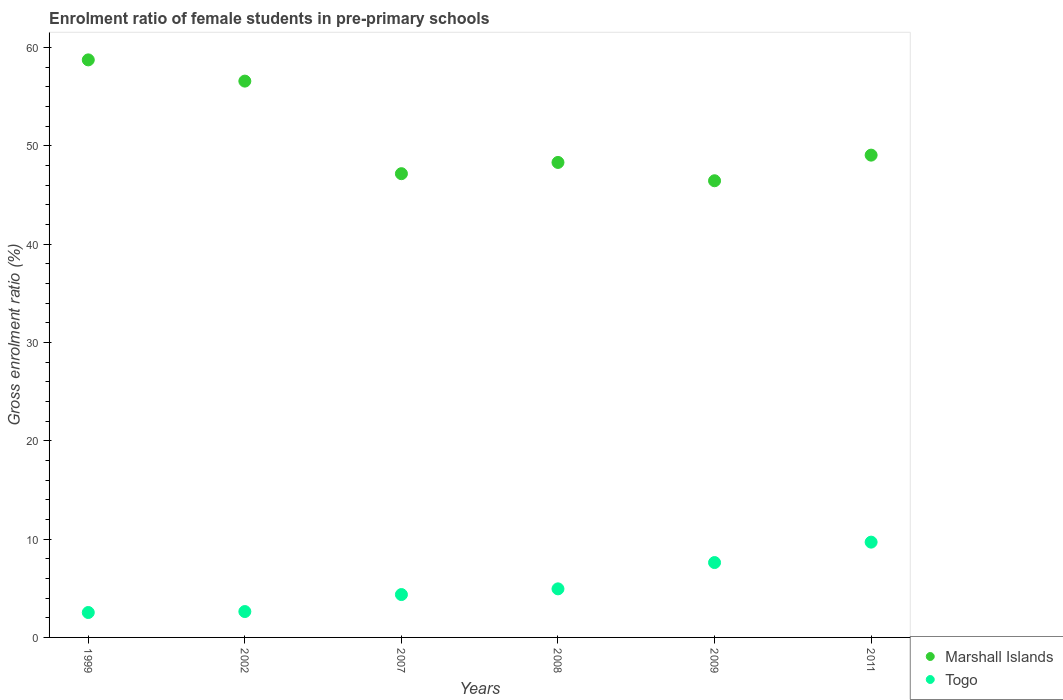How many different coloured dotlines are there?
Keep it short and to the point. 2. What is the enrolment ratio of female students in pre-primary schools in Togo in 2009?
Make the answer very short. 7.61. Across all years, what is the maximum enrolment ratio of female students in pre-primary schools in Togo?
Give a very brief answer. 9.69. Across all years, what is the minimum enrolment ratio of female students in pre-primary schools in Marshall Islands?
Your response must be concise. 46.44. What is the total enrolment ratio of female students in pre-primary schools in Togo in the graph?
Provide a succinct answer. 31.77. What is the difference between the enrolment ratio of female students in pre-primary schools in Marshall Islands in 2007 and that in 2011?
Your answer should be very brief. -1.89. What is the difference between the enrolment ratio of female students in pre-primary schools in Marshall Islands in 2011 and the enrolment ratio of female students in pre-primary schools in Togo in 2009?
Offer a terse response. 41.44. What is the average enrolment ratio of female students in pre-primary schools in Togo per year?
Provide a succinct answer. 5.29. In the year 2011, what is the difference between the enrolment ratio of female students in pre-primary schools in Marshall Islands and enrolment ratio of female students in pre-primary schools in Togo?
Your response must be concise. 39.36. What is the ratio of the enrolment ratio of female students in pre-primary schools in Marshall Islands in 1999 to that in 2007?
Provide a succinct answer. 1.25. Is the enrolment ratio of female students in pre-primary schools in Togo in 2008 less than that in 2011?
Ensure brevity in your answer.  Yes. What is the difference between the highest and the second highest enrolment ratio of female students in pre-primary schools in Marshall Islands?
Keep it short and to the point. 2.16. What is the difference between the highest and the lowest enrolment ratio of female students in pre-primary schools in Togo?
Your answer should be compact. 7.16. Does the enrolment ratio of female students in pre-primary schools in Togo monotonically increase over the years?
Ensure brevity in your answer.  Yes. How many dotlines are there?
Keep it short and to the point. 2. How many years are there in the graph?
Offer a terse response. 6. What is the difference between two consecutive major ticks on the Y-axis?
Give a very brief answer. 10. Does the graph contain any zero values?
Provide a short and direct response. No. Does the graph contain grids?
Your response must be concise. No. Where does the legend appear in the graph?
Provide a short and direct response. Bottom right. How many legend labels are there?
Provide a succinct answer. 2. How are the legend labels stacked?
Provide a short and direct response. Vertical. What is the title of the graph?
Make the answer very short. Enrolment ratio of female students in pre-primary schools. Does "Venezuela" appear as one of the legend labels in the graph?
Provide a short and direct response. No. What is the label or title of the X-axis?
Keep it short and to the point. Years. What is the label or title of the Y-axis?
Give a very brief answer. Gross enrolment ratio (%). What is the Gross enrolment ratio (%) in Marshall Islands in 1999?
Make the answer very short. 58.74. What is the Gross enrolment ratio (%) of Togo in 1999?
Offer a very short reply. 2.53. What is the Gross enrolment ratio (%) in Marshall Islands in 2002?
Make the answer very short. 56.58. What is the Gross enrolment ratio (%) in Togo in 2002?
Provide a short and direct response. 2.63. What is the Gross enrolment ratio (%) in Marshall Islands in 2007?
Provide a short and direct response. 47.16. What is the Gross enrolment ratio (%) of Togo in 2007?
Keep it short and to the point. 4.36. What is the Gross enrolment ratio (%) of Marshall Islands in 2008?
Offer a terse response. 48.31. What is the Gross enrolment ratio (%) in Togo in 2008?
Your answer should be very brief. 4.94. What is the Gross enrolment ratio (%) of Marshall Islands in 2009?
Give a very brief answer. 46.44. What is the Gross enrolment ratio (%) in Togo in 2009?
Offer a terse response. 7.61. What is the Gross enrolment ratio (%) of Marshall Islands in 2011?
Your answer should be very brief. 49.05. What is the Gross enrolment ratio (%) of Togo in 2011?
Your answer should be very brief. 9.69. Across all years, what is the maximum Gross enrolment ratio (%) of Marshall Islands?
Offer a very short reply. 58.74. Across all years, what is the maximum Gross enrolment ratio (%) of Togo?
Offer a very short reply. 9.69. Across all years, what is the minimum Gross enrolment ratio (%) in Marshall Islands?
Give a very brief answer. 46.44. Across all years, what is the minimum Gross enrolment ratio (%) of Togo?
Provide a short and direct response. 2.53. What is the total Gross enrolment ratio (%) of Marshall Islands in the graph?
Ensure brevity in your answer.  306.27. What is the total Gross enrolment ratio (%) in Togo in the graph?
Keep it short and to the point. 31.77. What is the difference between the Gross enrolment ratio (%) in Marshall Islands in 1999 and that in 2002?
Your answer should be compact. 2.16. What is the difference between the Gross enrolment ratio (%) in Togo in 1999 and that in 2002?
Your response must be concise. -0.1. What is the difference between the Gross enrolment ratio (%) of Marshall Islands in 1999 and that in 2007?
Provide a succinct answer. 11.57. What is the difference between the Gross enrolment ratio (%) of Togo in 1999 and that in 2007?
Your answer should be very brief. -1.83. What is the difference between the Gross enrolment ratio (%) of Marshall Islands in 1999 and that in 2008?
Provide a succinct answer. 10.43. What is the difference between the Gross enrolment ratio (%) of Togo in 1999 and that in 2008?
Your answer should be compact. -2.4. What is the difference between the Gross enrolment ratio (%) of Marshall Islands in 1999 and that in 2009?
Ensure brevity in your answer.  12.29. What is the difference between the Gross enrolment ratio (%) in Togo in 1999 and that in 2009?
Make the answer very short. -5.08. What is the difference between the Gross enrolment ratio (%) in Marshall Islands in 1999 and that in 2011?
Give a very brief answer. 9.69. What is the difference between the Gross enrolment ratio (%) of Togo in 1999 and that in 2011?
Offer a terse response. -7.16. What is the difference between the Gross enrolment ratio (%) in Marshall Islands in 2002 and that in 2007?
Keep it short and to the point. 9.41. What is the difference between the Gross enrolment ratio (%) of Togo in 2002 and that in 2007?
Ensure brevity in your answer.  -1.73. What is the difference between the Gross enrolment ratio (%) of Marshall Islands in 2002 and that in 2008?
Offer a very short reply. 8.27. What is the difference between the Gross enrolment ratio (%) of Togo in 2002 and that in 2008?
Provide a short and direct response. -2.31. What is the difference between the Gross enrolment ratio (%) of Marshall Islands in 2002 and that in 2009?
Give a very brief answer. 10.13. What is the difference between the Gross enrolment ratio (%) of Togo in 2002 and that in 2009?
Provide a short and direct response. -4.98. What is the difference between the Gross enrolment ratio (%) of Marshall Islands in 2002 and that in 2011?
Ensure brevity in your answer.  7.53. What is the difference between the Gross enrolment ratio (%) of Togo in 2002 and that in 2011?
Make the answer very short. -7.06. What is the difference between the Gross enrolment ratio (%) of Marshall Islands in 2007 and that in 2008?
Your response must be concise. -1.14. What is the difference between the Gross enrolment ratio (%) of Togo in 2007 and that in 2008?
Provide a short and direct response. -0.58. What is the difference between the Gross enrolment ratio (%) of Marshall Islands in 2007 and that in 2009?
Your response must be concise. 0.72. What is the difference between the Gross enrolment ratio (%) of Togo in 2007 and that in 2009?
Provide a short and direct response. -3.25. What is the difference between the Gross enrolment ratio (%) of Marshall Islands in 2007 and that in 2011?
Offer a very short reply. -1.89. What is the difference between the Gross enrolment ratio (%) in Togo in 2007 and that in 2011?
Offer a terse response. -5.33. What is the difference between the Gross enrolment ratio (%) in Marshall Islands in 2008 and that in 2009?
Your response must be concise. 1.86. What is the difference between the Gross enrolment ratio (%) of Togo in 2008 and that in 2009?
Your response must be concise. -2.67. What is the difference between the Gross enrolment ratio (%) of Marshall Islands in 2008 and that in 2011?
Offer a very short reply. -0.74. What is the difference between the Gross enrolment ratio (%) in Togo in 2008 and that in 2011?
Give a very brief answer. -4.75. What is the difference between the Gross enrolment ratio (%) of Marshall Islands in 2009 and that in 2011?
Give a very brief answer. -2.61. What is the difference between the Gross enrolment ratio (%) in Togo in 2009 and that in 2011?
Offer a very short reply. -2.08. What is the difference between the Gross enrolment ratio (%) in Marshall Islands in 1999 and the Gross enrolment ratio (%) in Togo in 2002?
Provide a succinct answer. 56.1. What is the difference between the Gross enrolment ratio (%) of Marshall Islands in 1999 and the Gross enrolment ratio (%) of Togo in 2007?
Provide a succinct answer. 54.38. What is the difference between the Gross enrolment ratio (%) of Marshall Islands in 1999 and the Gross enrolment ratio (%) of Togo in 2008?
Your response must be concise. 53.8. What is the difference between the Gross enrolment ratio (%) of Marshall Islands in 1999 and the Gross enrolment ratio (%) of Togo in 2009?
Your answer should be compact. 51.12. What is the difference between the Gross enrolment ratio (%) of Marshall Islands in 1999 and the Gross enrolment ratio (%) of Togo in 2011?
Keep it short and to the point. 49.05. What is the difference between the Gross enrolment ratio (%) of Marshall Islands in 2002 and the Gross enrolment ratio (%) of Togo in 2007?
Your answer should be very brief. 52.22. What is the difference between the Gross enrolment ratio (%) of Marshall Islands in 2002 and the Gross enrolment ratio (%) of Togo in 2008?
Ensure brevity in your answer.  51.64. What is the difference between the Gross enrolment ratio (%) in Marshall Islands in 2002 and the Gross enrolment ratio (%) in Togo in 2009?
Ensure brevity in your answer.  48.96. What is the difference between the Gross enrolment ratio (%) of Marshall Islands in 2002 and the Gross enrolment ratio (%) of Togo in 2011?
Provide a succinct answer. 46.89. What is the difference between the Gross enrolment ratio (%) in Marshall Islands in 2007 and the Gross enrolment ratio (%) in Togo in 2008?
Your response must be concise. 42.22. What is the difference between the Gross enrolment ratio (%) of Marshall Islands in 2007 and the Gross enrolment ratio (%) of Togo in 2009?
Make the answer very short. 39.55. What is the difference between the Gross enrolment ratio (%) of Marshall Islands in 2007 and the Gross enrolment ratio (%) of Togo in 2011?
Ensure brevity in your answer.  37.47. What is the difference between the Gross enrolment ratio (%) of Marshall Islands in 2008 and the Gross enrolment ratio (%) of Togo in 2009?
Your answer should be very brief. 40.69. What is the difference between the Gross enrolment ratio (%) in Marshall Islands in 2008 and the Gross enrolment ratio (%) in Togo in 2011?
Offer a terse response. 38.62. What is the difference between the Gross enrolment ratio (%) in Marshall Islands in 2009 and the Gross enrolment ratio (%) in Togo in 2011?
Offer a terse response. 36.75. What is the average Gross enrolment ratio (%) of Marshall Islands per year?
Provide a succinct answer. 51.05. What is the average Gross enrolment ratio (%) in Togo per year?
Offer a very short reply. 5.29. In the year 1999, what is the difference between the Gross enrolment ratio (%) in Marshall Islands and Gross enrolment ratio (%) in Togo?
Make the answer very short. 56.2. In the year 2002, what is the difference between the Gross enrolment ratio (%) of Marshall Islands and Gross enrolment ratio (%) of Togo?
Offer a terse response. 53.95. In the year 2007, what is the difference between the Gross enrolment ratio (%) of Marshall Islands and Gross enrolment ratio (%) of Togo?
Ensure brevity in your answer.  42.8. In the year 2008, what is the difference between the Gross enrolment ratio (%) in Marshall Islands and Gross enrolment ratio (%) in Togo?
Your response must be concise. 43.37. In the year 2009, what is the difference between the Gross enrolment ratio (%) in Marshall Islands and Gross enrolment ratio (%) in Togo?
Your answer should be compact. 38.83. In the year 2011, what is the difference between the Gross enrolment ratio (%) of Marshall Islands and Gross enrolment ratio (%) of Togo?
Your answer should be very brief. 39.36. What is the ratio of the Gross enrolment ratio (%) of Marshall Islands in 1999 to that in 2002?
Give a very brief answer. 1.04. What is the ratio of the Gross enrolment ratio (%) in Togo in 1999 to that in 2002?
Your answer should be very brief. 0.96. What is the ratio of the Gross enrolment ratio (%) of Marshall Islands in 1999 to that in 2007?
Provide a succinct answer. 1.25. What is the ratio of the Gross enrolment ratio (%) of Togo in 1999 to that in 2007?
Provide a succinct answer. 0.58. What is the ratio of the Gross enrolment ratio (%) in Marshall Islands in 1999 to that in 2008?
Make the answer very short. 1.22. What is the ratio of the Gross enrolment ratio (%) in Togo in 1999 to that in 2008?
Provide a short and direct response. 0.51. What is the ratio of the Gross enrolment ratio (%) in Marshall Islands in 1999 to that in 2009?
Your answer should be very brief. 1.26. What is the ratio of the Gross enrolment ratio (%) in Togo in 1999 to that in 2009?
Ensure brevity in your answer.  0.33. What is the ratio of the Gross enrolment ratio (%) of Marshall Islands in 1999 to that in 2011?
Ensure brevity in your answer.  1.2. What is the ratio of the Gross enrolment ratio (%) in Togo in 1999 to that in 2011?
Provide a short and direct response. 0.26. What is the ratio of the Gross enrolment ratio (%) in Marshall Islands in 2002 to that in 2007?
Make the answer very short. 1.2. What is the ratio of the Gross enrolment ratio (%) of Togo in 2002 to that in 2007?
Make the answer very short. 0.6. What is the ratio of the Gross enrolment ratio (%) in Marshall Islands in 2002 to that in 2008?
Your response must be concise. 1.17. What is the ratio of the Gross enrolment ratio (%) of Togo in 2002 to that in 2008?
Offer a terse response. 0.53. What is the ratio of the Gross enrolment ratio (%) of Marshall Islands in 2002 to that in 2009?
Your response must be concise. 1.22. What is the ratio of the Gross enrolment ratio (%) of Togo in 2002 to that in 2009?
Provide a succinct answer. 0.35. What is the ratio of the Gross enrolment ratio (%) of Marshall Islands in 2002 to that in 2011?
Ensure brevity in your answer.  1.15. What is the ratio of the Gross enrolment ratio (%) in Togo in 2002 to that in 2011?
Your response must be concise. 0.27. What is the ratio of the Gross enrolment ratio (%) of Marshall Islands in 2007 to that in 2008?
Provide a short and direct response. 0.98. What is the ratio of the Gross enrolment ratio (%) of Togo in 2007 to that in 2008?
Ensure brevity in your answer.  0.88. What is the ratio of the Gross enrolment ratio (%) in Marshall Islands in 2007 to that in 2009?
Your answer should be very brief. 1.02. What is the ratio of the Gross enrolment ratio (%) of Togo in 2007 to that in 2009?
Ensure brevity in your answer.  0.57. What is the ratio of the Gross enrolment ratio (%) in Marshall Islands in 2007 to that in 2011?
Your answer should be compact. 0.96. What is the ratio of the Gross enrolment ratio (%) in Togo in 2007 to that in 2011?
Your response must be concise. 0.45. What is the ratio of the Gross enrolment ratio (%) in Marshall Islands in 2008 to that in 2009?
Offer a very short reply. 1.04. What is the ratio of the Gross enrolment ratio (%) of Togo in 2008 to that in 2009?
Offer a very short reply. 0.65. What is the ratio of the Gross enrolment ratio (%) of Togo in 2008 to that in 2011?
Provide a succinct answer. 0.51. What is the ratio of the Gross enrolment ratio (%) of Marshall Islands in 2009 to that in 2011?
Your response must be concise. 0.95. What is the ratio of the Gross enrolment ratio (%) in Togo in 2009 to that in 2011?
Your response must be concise. 0.79. What is the difference between the highest and the second highest Gross enrolment ratio (%) in Marshall Islands?
Offer a very short reply. 2.16. What is the difference between the highest and the second highest Gross enrolment ratio (%) of Togo?
Your answer should be compact. 2.08. What is the difference between the highest and the lowest Gross enrolment ratio (%) of Marshall Islands?
Your answer should be very brief. 12.29. What is the difference between the highest and the lowest Gross enrolment ratio (%) of Togo?
Offer a very short reply. 7.16. 